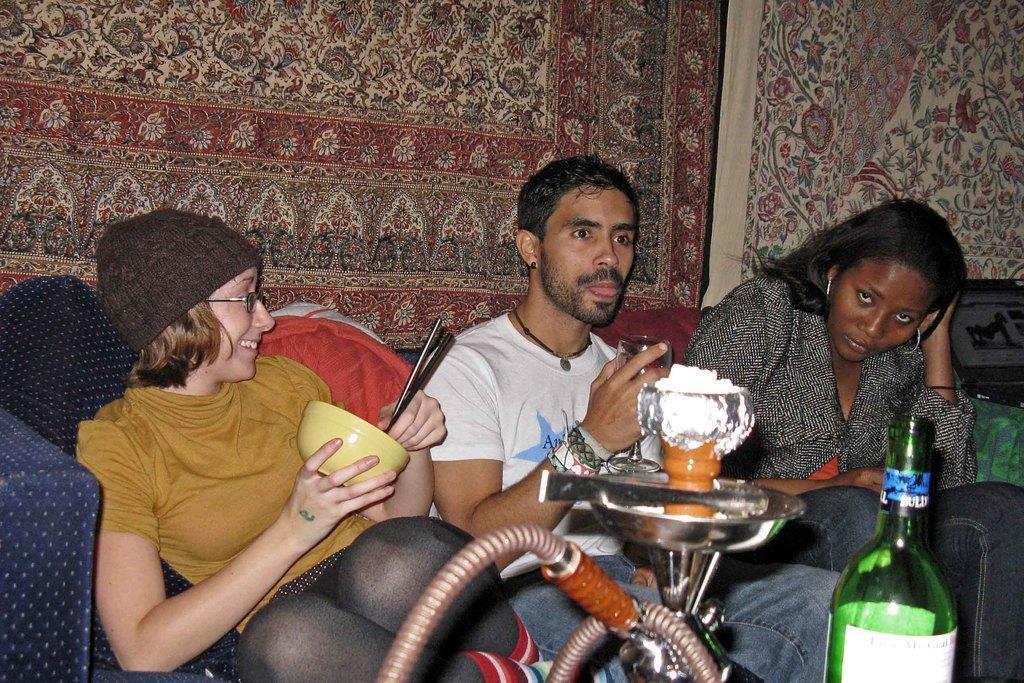Can you describe this image briefly? In this picture, we see three people sitting on sofa. Woman in yellow t-shirt is holding bowl in her hand, man in white t-shirt is holding glass in his hand. In front of them, we see hookah pot and green color alcohol bottle. Behind them, we see a colorful sheet. 